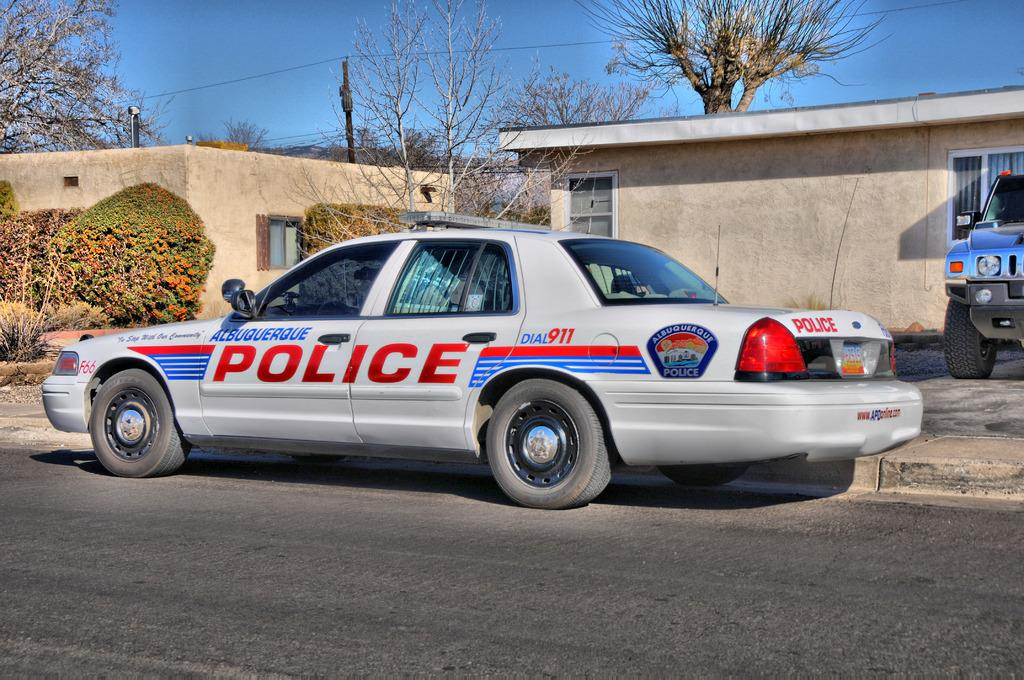<image>
Create a compact narrative representing the image presented. A silver police car that says Albuquerque Police is parked in front of a tan house. 